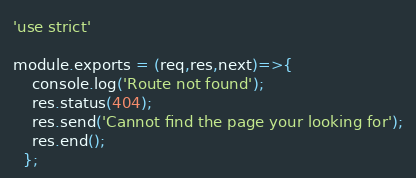<code> <loc_0><loc_0><loc_500><loc_500><_JavaScript_>'use strict'

module.exports = (req,res,next)=>{
    console.log('Route not found');
    res.status(404);
    res.send('Cannot find the page your looking for');
    res.end();
  };</code> 